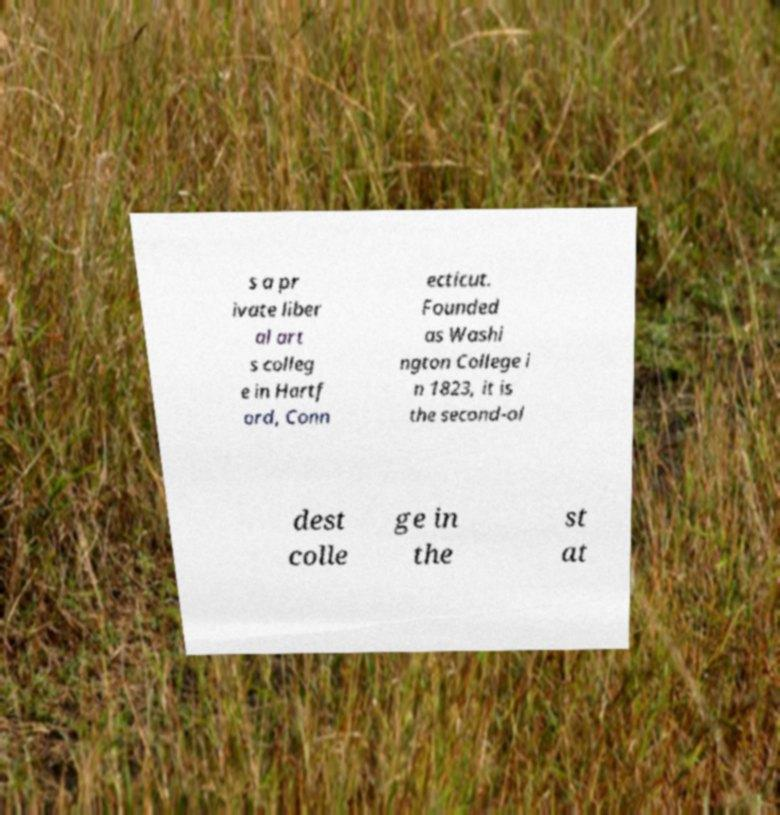Please read and relay the text visible in this image. What does it say? s a pr ivate liber al art s colleg e in Hartf ord, Conn ecticut. Founded as Washi ngton College i n 1823, it is the second-ol dest colle ge in the st at 